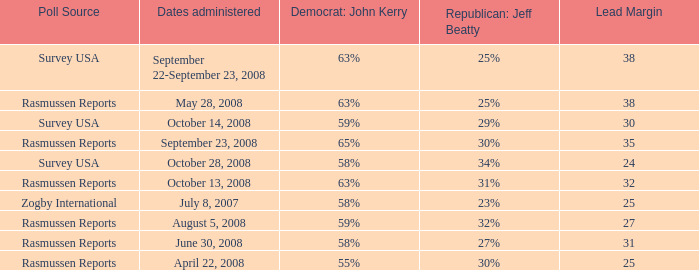Who is the poll source that has Republican: Jeff Beatty behind at 27%? Rasmussen Reports. 